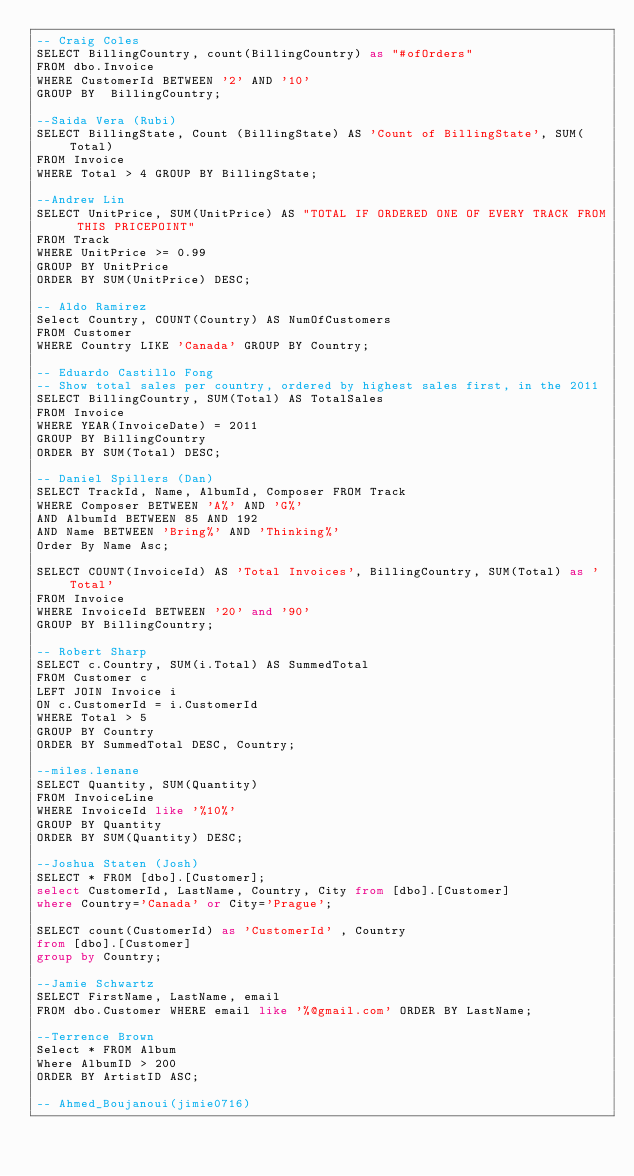Convert code to text. <code><loc_0><loc_0><loc_500><loc_500><_SQL_>-- Craig Coles
SELECT BillingCountry, count(BillingCountry) as "#ofOrders" 
FROM dbo.Invoice 
WHERE CustomerId BETWEEN '2' AND '10' 
GROUP BY  BillingCountry;

--Saida Vera (Rubi)
SELECT BillingState, Count (BillingState) AS 'Count of BillingState', SUM(Total)
FROM Invoice 
WHERE Total > 4 GROUP BY BillingState;

--Andrew Lin
SELECT UnitPrice, SUM(UnitPrice) AS "TOTAL IF ORDERED ONE OF EVERY TRACK FROM THIS PRICEPOINT" 
FROM Track 
WHERE UnitPrice >= 0.99 
GROUP BY UnitPrice 
ORDER BY SUM(UnitPrice) DESC;

-- Aldo Ramirez
Select Country, COUNT(Country) AS NumOfCustomers
FROM Customer 
WHERE Country LIKE 'Canada' GROUP BY Country;

-- Eduardo Castillo Fong
-- Show total sales per country, ordered by highest sales first, in the 2011
SELECT BillingCountry, SUM(Total) AS TotalSales 
FROM Invoice 
WHERE YEAR(InvoiceDate) = 2011 
GROUP BY BillingCountry 
ORDER BY SUM(Total) DESC;

-- Daniel Spillers (Dan)
SELECT TrackId, Name, AlbumId, Composer FROM Track
WHERE Composer BETWEEN 'A%' AND 'G%'
AND AlbumId BETWEEN 85 AND 192
AND Name BETWEEN 'Bring%' AND 'Thinking%'
Order By Name Asc;

SELECT COUNT(InvoiceId) AS 'Total Invoices', BillingCountry, SUM(Total) as 'Total' 
FROM Invoice
WHERE InvoiceId BETWEEN '20' and '90'
GROUP BY BillingCountry;

-- Robert Sharp 
SELECT c.Country, SUM(i.Total) AS SummedTotal
FROM Customer c 
LEFT JOIN Invoice i
ON c.CustomerId = i.CustomerId
WHERE Total > 5 
GROUP BY Country 
ORDER BY SummedTotal DESC, Country;

--miles.lenane
SELECT Quantity, SUM(Quantity) 
FROM InvoiceLine 
WHERE InvoiceId like '%10%' 
GROUP BY Quantity 
ORDER BY SUM(Quantity) DESC; 

--Joshua Staten (Josh)
SELECT * FROM [dbo].[Customer];
select CustomerId, LastName, Country, City from [dbo].[Customer]
where Country='Canada' or City='Prague';

SELECT count(CustomerId) as 'CustomerId' , Country
from [dbo].[Customer]
group by Country; 

--Jamie Schwartz
SELECT FirstName, LastName, email 
FROM dbo.Customer WHERE email like '%@gmail.com' ORDER BY LastName;

--Terrence Brown
Select * FROM Album
Where AlbumID > 200
ORDER BY ArtistID ASC;

-- Ahmed_Boujanoui(jimie0716)</code> 